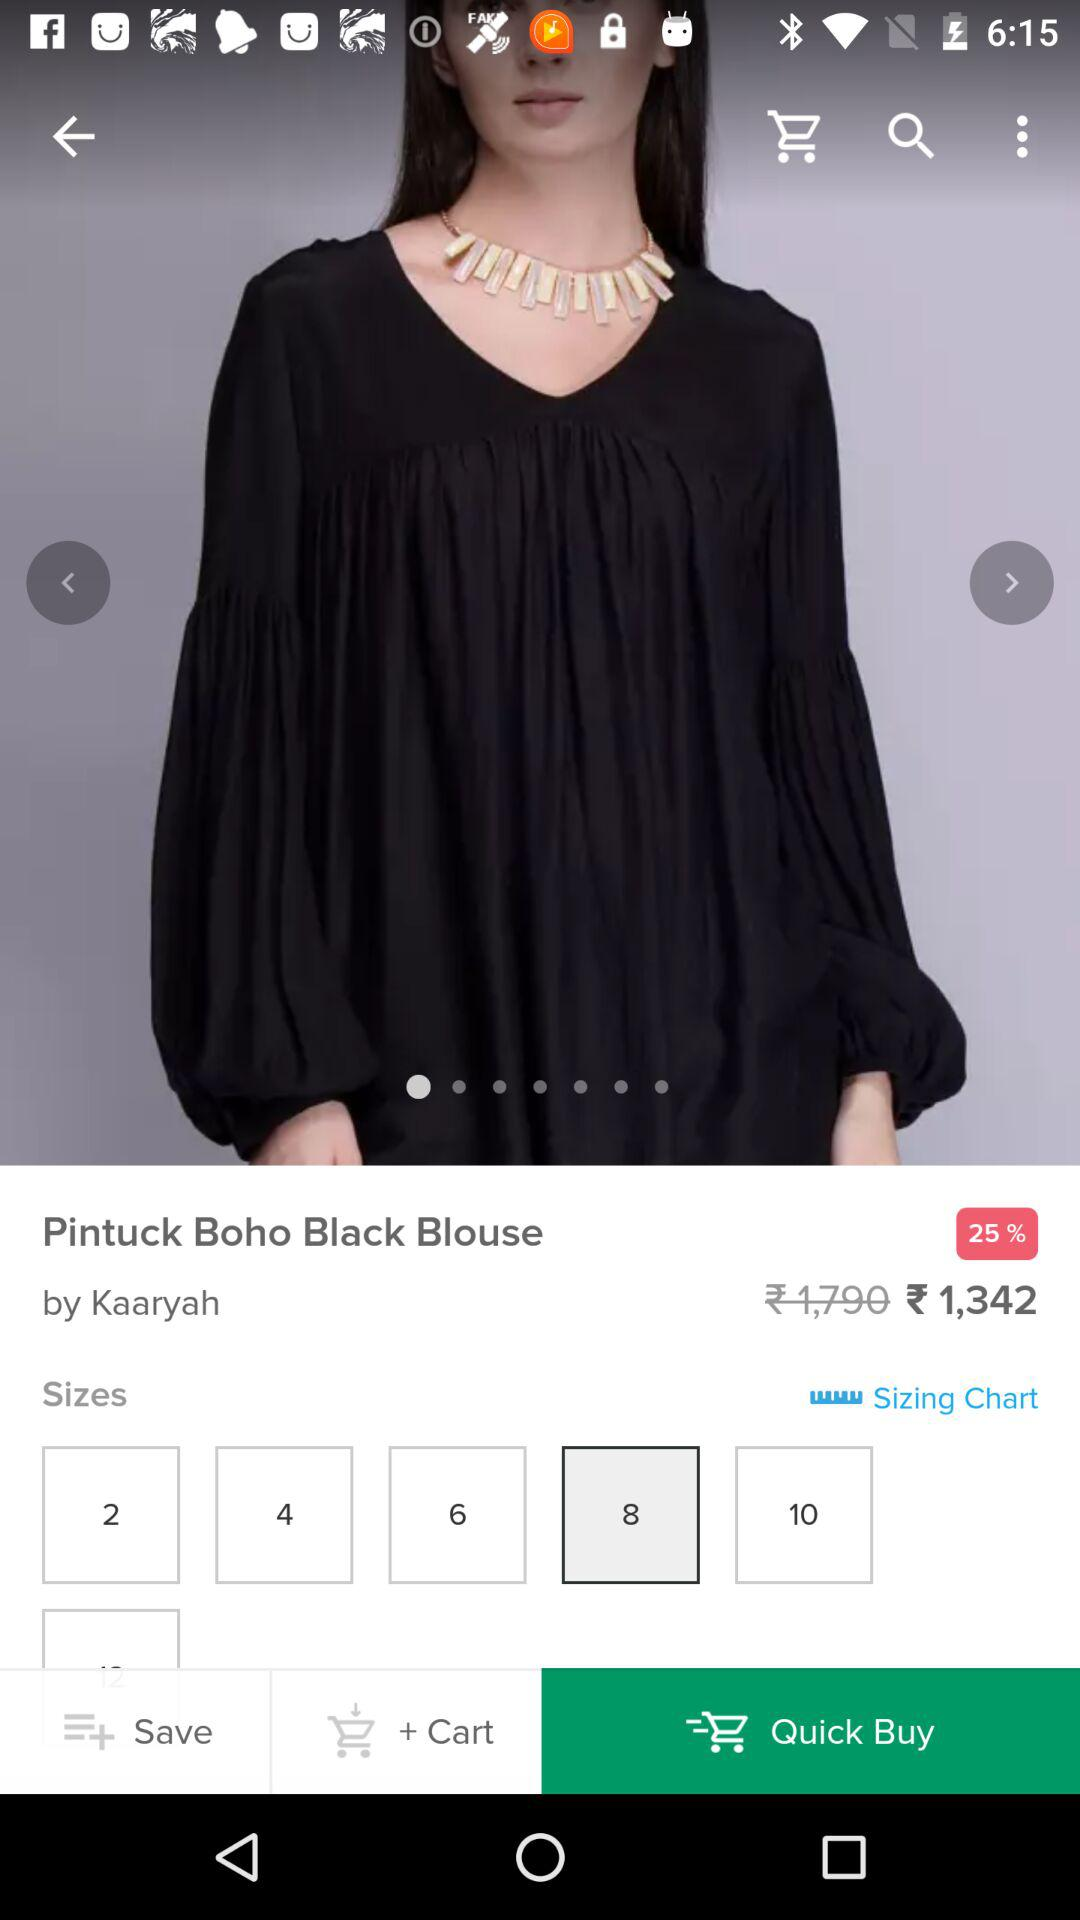What is the difference between the original price and the sale price?
Answer the question using a single word or phrase. 448 